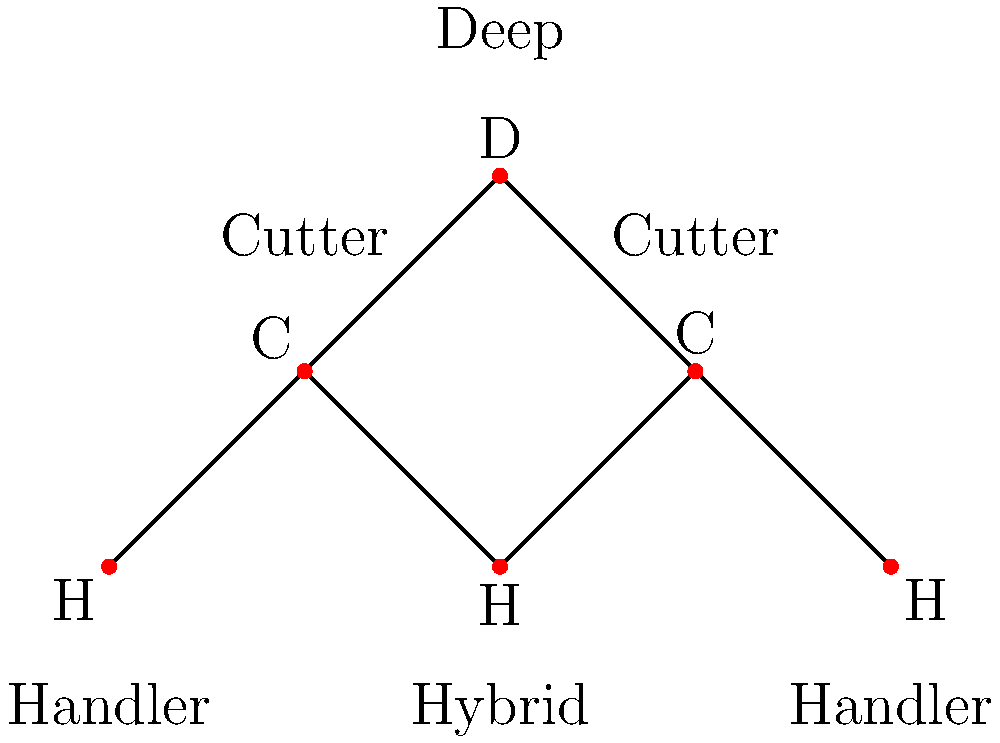In an Ultimate Frisbee game, players are positioned on the field as shown in the graph. Handlers (H) are represented by the bottom vertices, Cutters (C) by the middle vertices, and the Deep (D) by the top vertex. What is the minimum number of players that need to be removed to disconnect the Handlers from the Deep player? To solve this problem, we need to use the concept of vertex connectivity in graph theory. We want to find the minimum number of vertices that, when removed, will disconnect the Handlers from the Deep player.

Step 1: Identify the Handlers and the Deep player.
- Handlers: vertices labeled H (3 in total)
- Deep player: vertex labeled D (1 in total)

Step 2: Analyze the possible paths from Handlers to the Deep player.
- All paths from Handlers to the Deep player must go through at least one Cutter.

Step 3: Identify the critical vertices.
- The two Cutters (labeled C) are the only vertices connecting the Handlers to the Deep player.

Step 4: Determine the minimum number of vertices to remove.
- Removing both Cutters will disconnect all Handlers from the Deep player.
- Removing only one Cutter will still leave a path from Handlers to the Deep player through the other Cutter.

Step 5: Conclude the minimum number.
- The minimum number of players (vertices) that need to be removed to disconnect the Handlers from the Deep player is 2, which are the two Cutters.
Answer: 2 